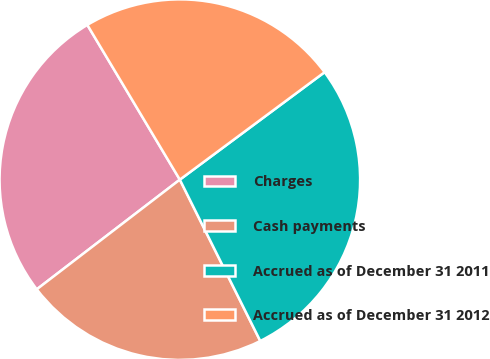Convert chart to OTSL. <chart><loc_0><loc_0><loc_500><loc_500><pie_chart><fcel>Charges<fcel>Cash payments<fcel>Accrued as of December 31 2011<fcel>Accrued as of December 31 2012<nl><fcel>26.83%<fcel>21.95%<fcel>27.8%<fcel>23.41%<nl></chart> 